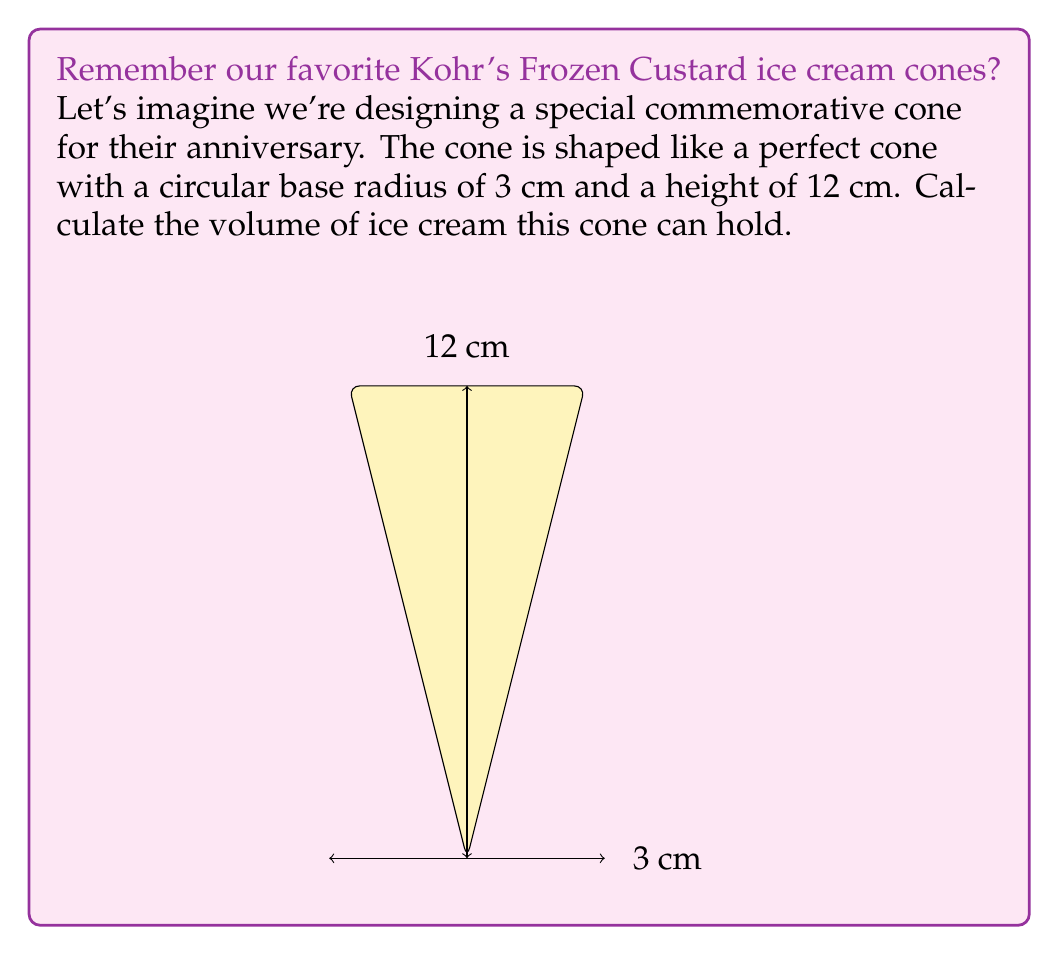Could you help me with this problem? To calculate the volume of a cone, we use the formula:

$$V = \frac{1}{3}\pi r^2 h$$

Where:
$V$ = volume
$r$ = radius of the base
$h$ = height of the cone

Given:
$r = 3$ cm
$h = 12$ cm

Let's substitute these values into the formula:

$$V = \frac{1}{3}\pi (3\text{ cm})^2 (12\text{ cm})$$

Simplifying:
$$V = \frac{1}{3}\pi (9\text{ cm}^2) (12\text{ cm})$$
$$V = 36\pi\text{ cm}^3$$

To get the final numerical value, let's use $\pi \approx 3.14159$:

$$V \approx 36 \times 3.14159\text{ cm}^3$$
$$V \approx 113.09724\text{ cm}^3$$

Rounding to two decimal places:
$$V \approx 113.10\text{ cm}^3$$

This is the volume of ice cream our commemorative Kohr's Frozen Custard cone can hold!
Answer: $113.10\text{ cm}^3$ 